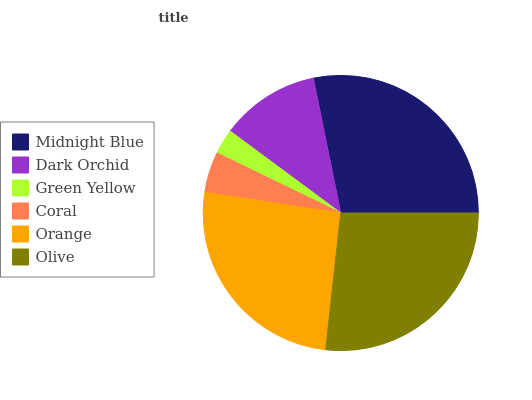Is Green Yellow the minimum?
Answer yes or no. Yes. Is Midnight Blue the maximum?
Answer yes or no. Yes. Is Dark Orchid the minimum?
Answer yes or no. No. Is Dark Orchid the maximum?
Answer yes or no. No. Is Midnight Blue greater than Dark Orchid?
Answer yes or no. Yes. Is Dark Orchid less than Midnight Blue?
Answer yes or no. Yes. Is Dark Orchid greater than Midnight Blue?
Answer yes or no. No. Is Midnight Blue less than Dark Orchid?
Answer yes or no. No. Is Orange the high median?
Answer yes or no. Yes. Is Dark Orchid the low median?
Answer yes or no. Yes. Is Dark Orchid the high median?
Answer yes or no. No. Is Olive the low median?
Answer yes or no. No. 